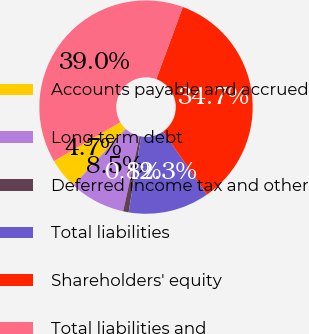Convert chart to OTSL. <chart><loc_0><loc_0><loc_500><loc_500><pie_chart><fcel>Accounts payable and accrued<fcel>Long term debt<fcel>Deferred income tax and other<fcel>Total liabilities<fcel>Shareholders' equity<fcel>Total liabilities and<nl><fcel>4.65%<fcel>8.47%<fcel>0.83%<fcel>12.3%<fcel>34.7%<fcel>39.05%<nl></chart> 